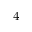Convert formula to latex. <formula><loc_0><loc_0><loc_500><loc_500>^ { 4 }</formula> 